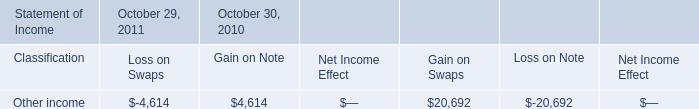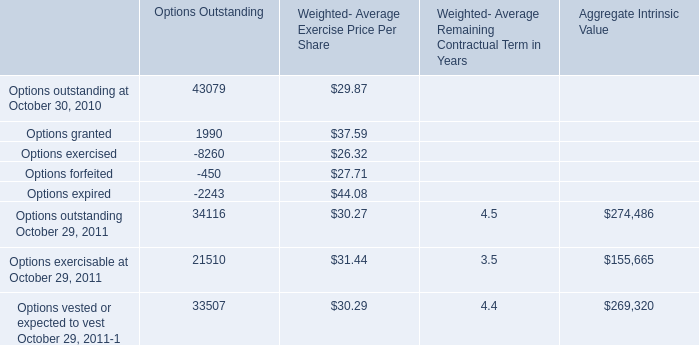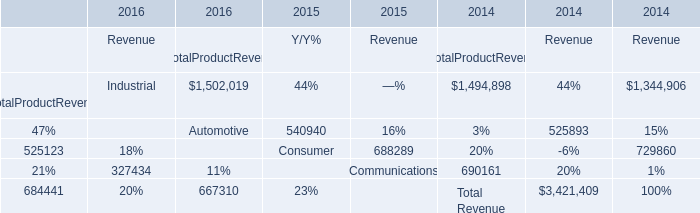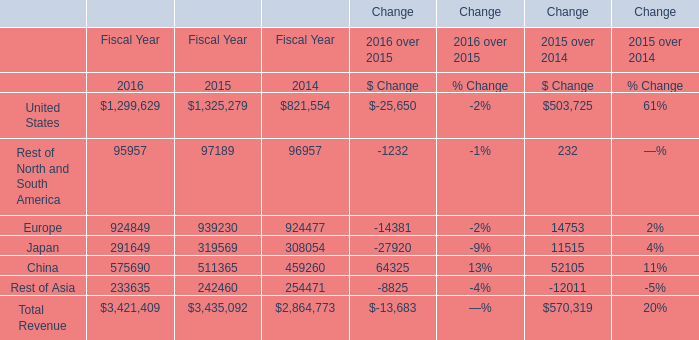what is the percentage change in cash flow hedges in 2011 compare to the 2010? 
Computations: ((153.7 - 139.9) / 139.9)
Answer: 0.09864. 